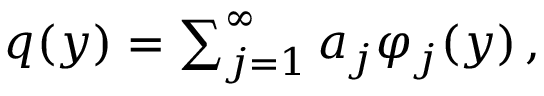<formula> <loc_0><loc_0><loc_500><loc_500>\begin{array} { r } { q ( y ) = \sum _ { j = 1 } ^ { \infty } a _ { j } \varphi _ { j } ( y ) \, , } \end{array}</formula> 